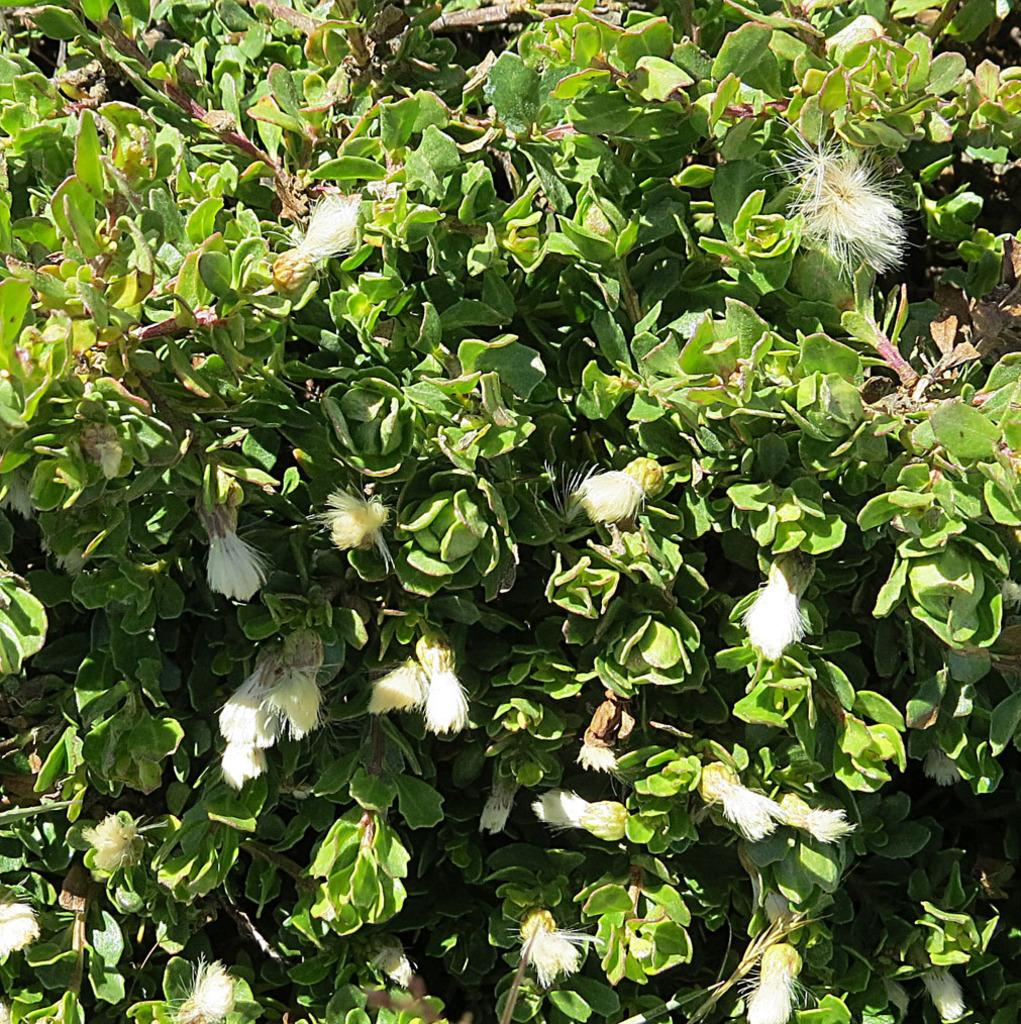What type of living organisms can be seen in the image? Plants can be seen in the image. What color are the flowers on the plants? The flowers on the plants are white-colored. What type of journey is the finger taking in the image? There is no finger present in the image, so it cannot be taking any journey. 